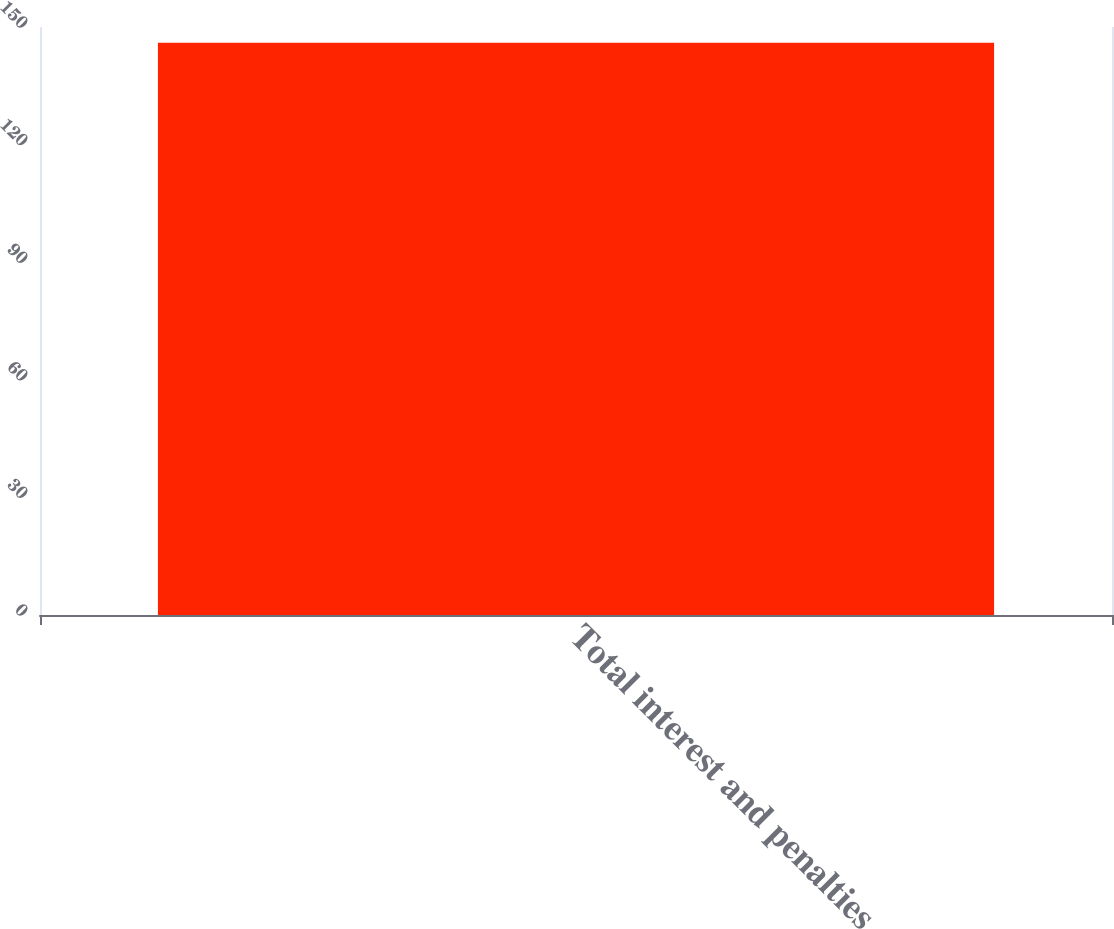Convert chart to OTSL. <chart><loc_0><loc_0><loc_500><loc_500><bar_chart><fcel>Total interest and penalties<nl><fcel>146<nl></chart> 